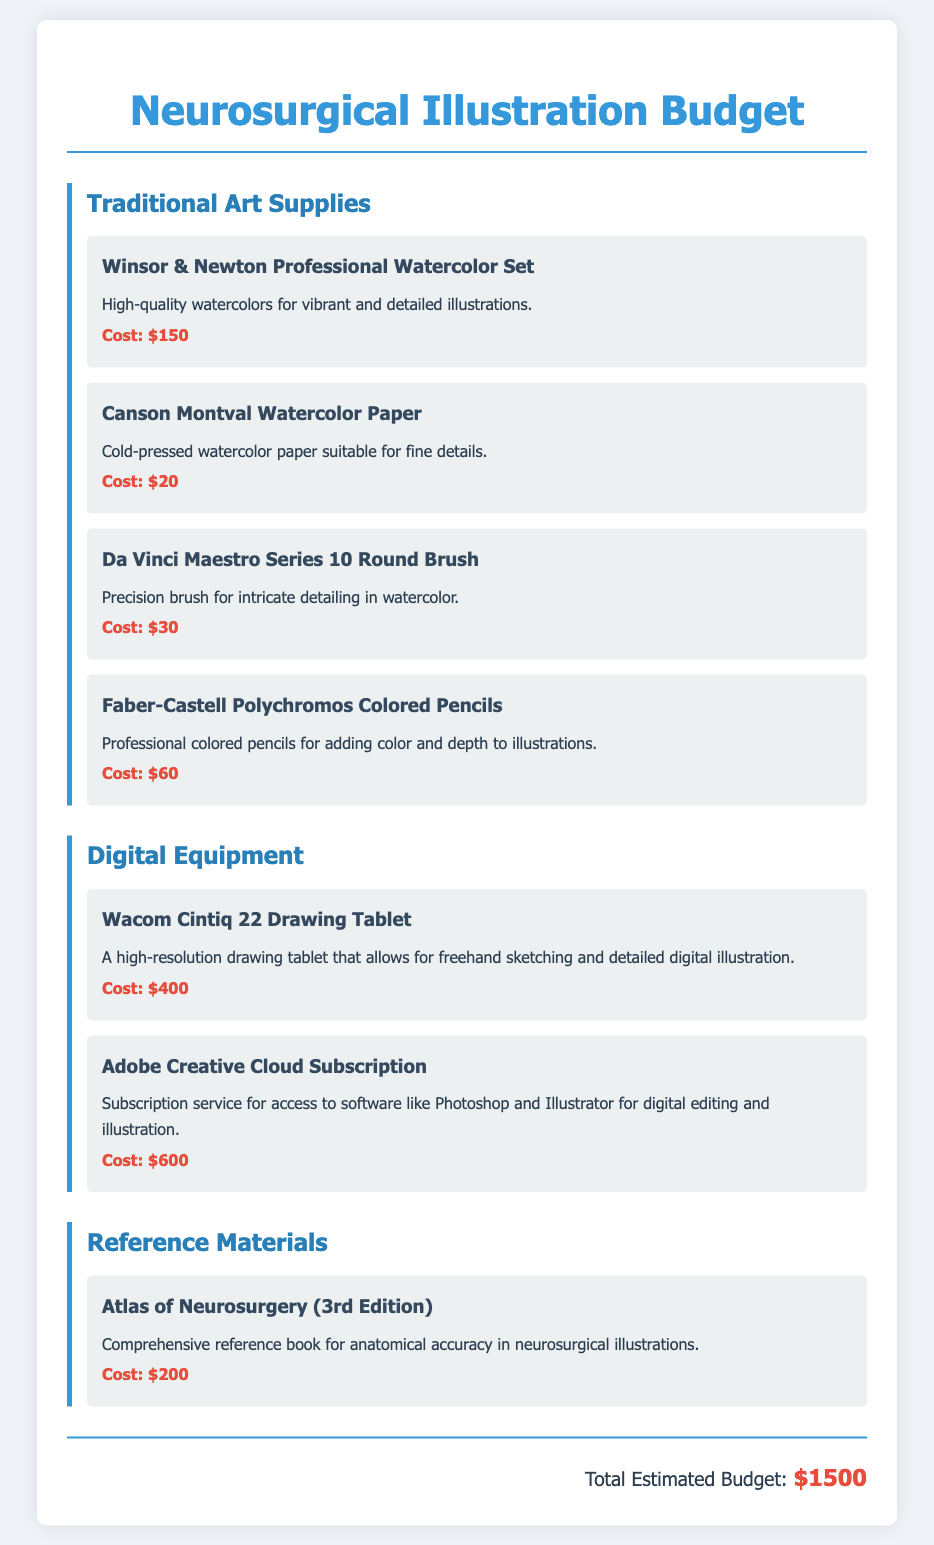What is the total estimated budget? The total estimated budget is found at the end of the document, summarizing all art supplies and tools costs.
Answer: $1500 How much does the Winsor & Newton Professional Watercolor Set cost? The specific cost of the Winsor & Newton Professional Watercolor Set is indicated in the traditional art supplies section.
Answer: $150 What type of reference material is included in the budget? The document specifies a book as the reference material needed for anatomical accuracy.
Answer: Atlas of Neurosurgery (3rd Edition) How much does the Adobe Creative Cloud Subscription cost? The cost of the Adobe Creative Cloud Subscription is noted in the digital equipment category of the budget.
Answer: $600 Which brush is mentioned for intricate detailing? The item that highlights a precision brush for intricate detailing is explicitly named in the traditional art supplies section.
Answer: Da Vinci Maestro Series 10 Round Brush What is the cost of Canson Montval Watercolor Paper? The document lists the cost for Canson Montval Watercolor Paper as part of the budget items.
Answer: $20 What are the two categories of supplies included in this budget? The budget divides the supplies into specific categories, focusing on different types of materials/tools.
Answer: Traditional Art Supplies, Digital Equipment Which digital equipment is listed as a drawing tablet? The document specifies the type of digital equipment used for drawing and illustrating in a dedicated section.
Answer: Wacom Cintiq 22 Drawing Tablet 